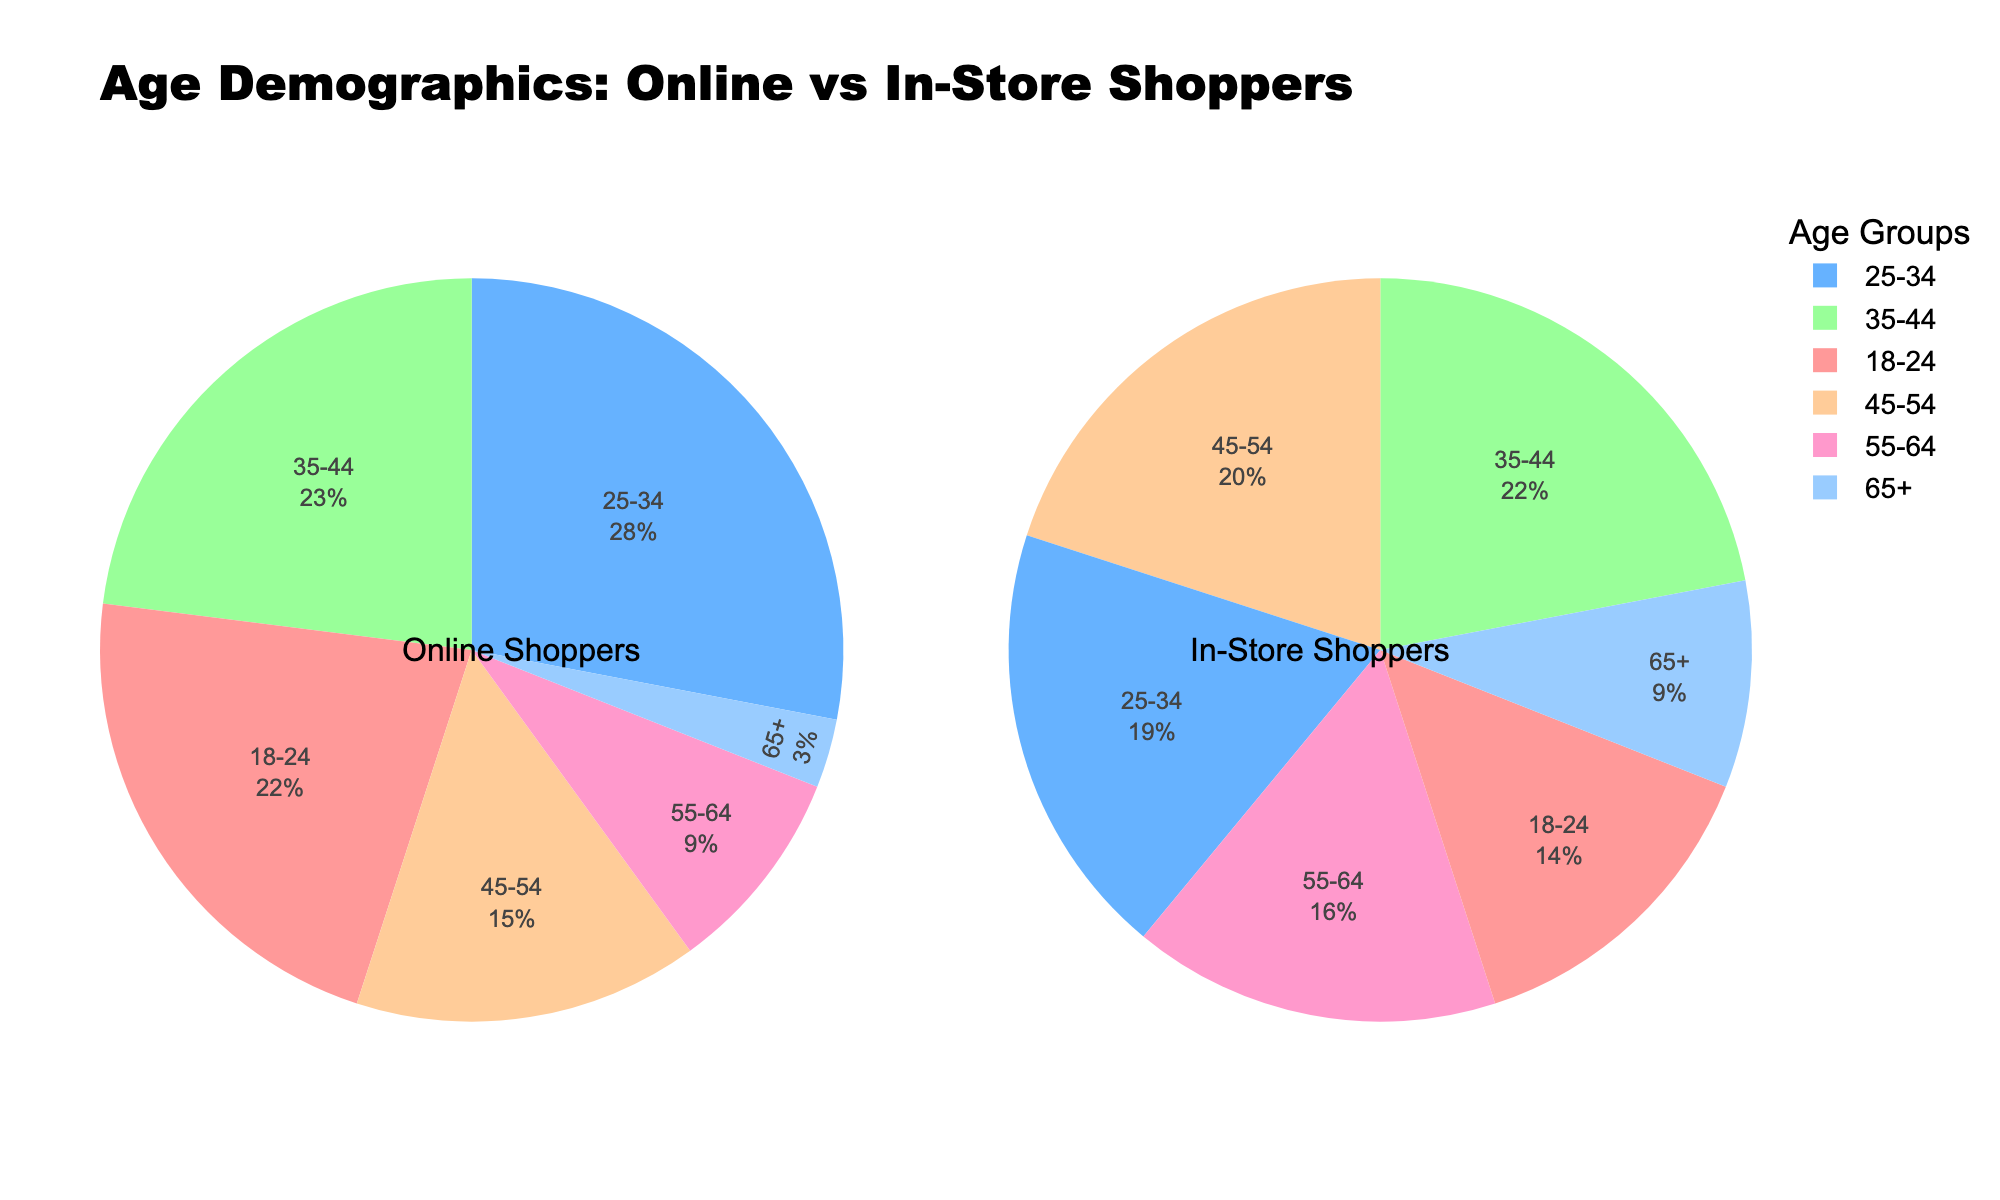What is the most represented age group among online shoppers? Look at the pie chart for Online Shoppers and observe which segment is the largest. The 25-34 age group occupies the largest segment.
Answer: 25-34 Which age group has a higher percentage of in-store shoppers compared to online shoppers? Compare the percentages of in-store and online shoppers for each age group. The age groups 45-54, 55-64, and 65+ have a higher percentage of in-store shoppers compared to online shoppers.
Answer: 45-54, 55-64, 65+ Which age group has the lowest representation among online shoppers? Look at the pie chart for Online Shoppers and observe which segment is the smallest. The 65+ age group occupies the smallest segment.
Answer: 65+ Which age groups have double-digit percentages for online shoppers? Review the pie chart for Online Shoppers and identify the age groups that have percentages of 10% or higher. The age groups 18-24, 25-34, 35-44, and 45-54 have double-digit percentages.
Answer: 18-24, 25-34, 35-44, 45-54 What is the combined percentage of online and in-store shoppers aged 35-44? Sum the percentages of online and in-store shoppers for the 35-44 age group. 23% (online) + 22% (in-store) = 45%.
Answer: 45% How does the percentage of online shoppers aged 25-34 compare to in-store shoppers of the same age group? Examine the pie charts for both online and in-store shoppers, focusing on the 25-34 age group. Online shoppers (28%) have a higher percentage than in-store shoppers (19%).
Answer: Higher For which age group does the percentage representation differ the most between online and in-store shoppers? Calculate the differences between the online and in-store percentages for each age group and identify the largest one. Age group 25-34 has the largest difference: 28% (online) - 19% (in-store) = 9%.
Answer: 25-34 What is the average percentage of in-store shoppers aged 45-64? Sum the percentages of in-store shoppers for the 45-54 and 55-64 age groups and divide by 2. (20% + 16%) / 2 = 18%.
Answer: 18% In which charts are the 18-24 age group sections shown in red? Identify the color used for the 18-24 age group in both charts. Both the pie chart for Online Shoppers and the pie chart for In-Store Shoppers show the 18-24 age group in red.
Answer: Both If you combine the percentages of shoppers aged 55+ for both online and in-store, which mode (online or in-store) captures a larger combined percentage? Add the percentages for the 55-64 and 65+ age groups for both online and in-store shoppers. Online: 9% (55-64) + 3% (65+) = 12%. In-Store: 16% (55-64) + 9% (65+) = 25%. Therefore, in-store captures a larger combined percentage.
Answer: In-store 